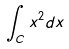Convert formula to latex. <formula><loc_0><loc_0><loc_500><loc_500>\int _ { C } x ^ { 2 } d x</formula> 